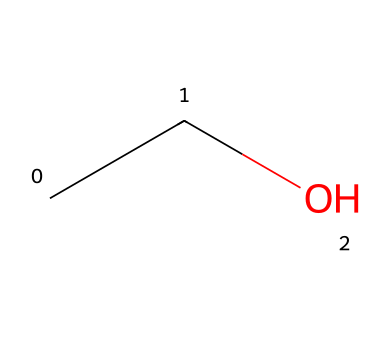What is the molecular formula of the compound shown? The molecular formula is derived from counting the number of carbon (C), hydrogen (H), and oxygen (O) atoms in the structure represented by the SMILES. In CCO, there are 2 carbon atoms, 6 hydrogen atoms, and 1 oxygen atom. Therefore, the molecular formula is C2H6O.
Answer: C2H6O How many carbon atoms are present in ethanol? The SMILES representation has two carbon atoms indicated by 'CC'.
Answer: 2 What type of functional group is present in this chemical? The 'O' in the SMILES indicates an alcohol group (-OH) attached to a carbon atom, which is specific to ethanol.
Answer: alcohol Is ethanol a polar compound? Ethanol has a hydroxyl group (-OH) that is polar due to the electronegativity of oxygen, making the molecule polar overall.
Answer: yes Does ethanol have the potential to be flammable? Ethanol's aliphatic structure contains carbon and hydrogen, which are flammable, and it readily ignites in the presence of heat or flame.
Answer: yes How many hydrogen atoms are bonded to the terminal carbon in ethanol? In the structure, the terminal carbon (the first carbon in the 'CC') is bonded to three hydrogen atoms and one carbon atom.
Answer: 3 What state is ethanol typically found in at room temperature? Ethanol is a liquid at room temperature due to its molecular interactions and relatively low molecular weight, which causes it not to solidify.
Answer: liquid 